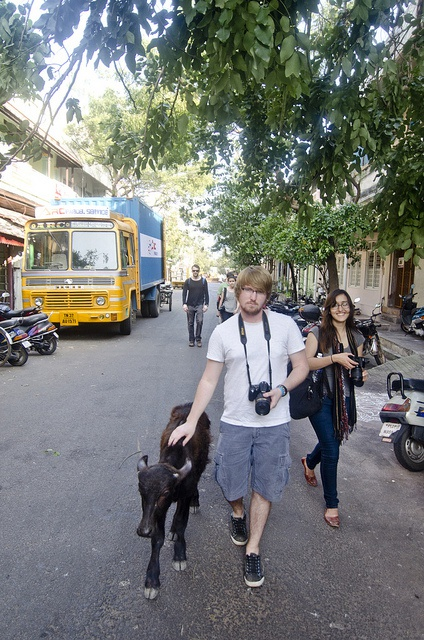Describe the objects in this image and their specific colors. I can see people in gray, lavender, and darkgray tones, truck in gray, lightgray, darkgray, and orange tones, people in gray, black, darkgray, and navy tones, cow in gray, black, and darkgray tones, and motorcycle in gray, black, and darkgray tones in this image. 